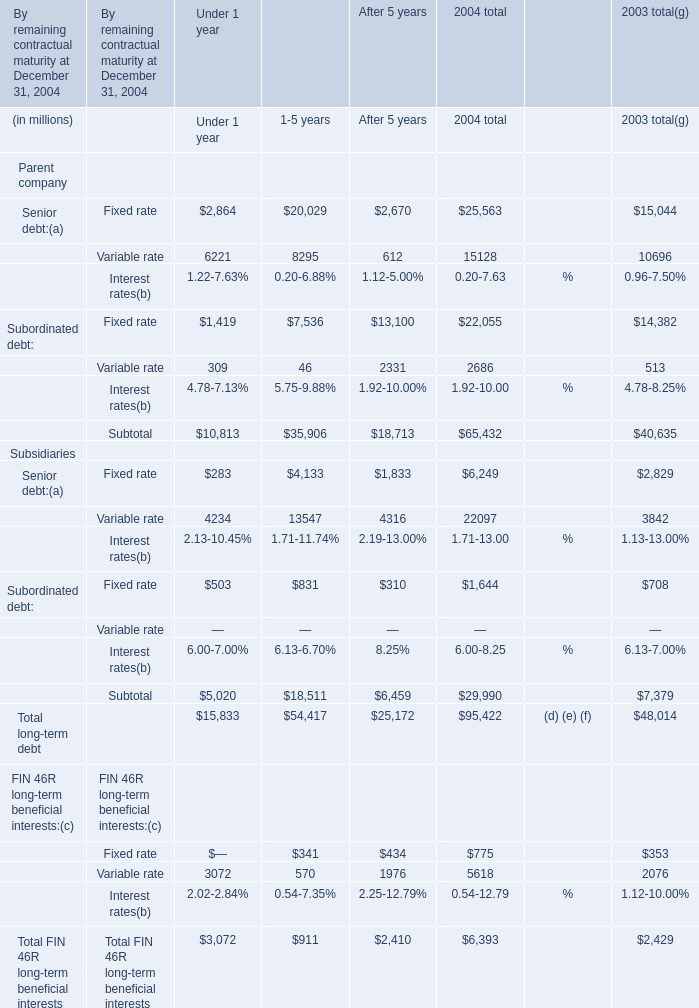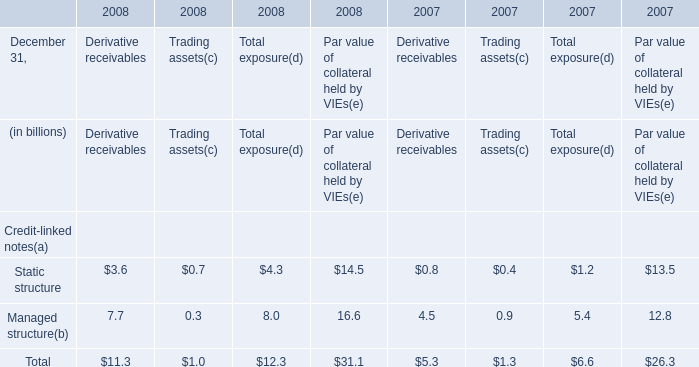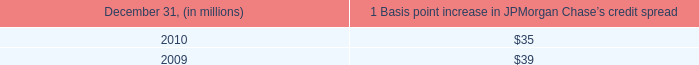on what percent of trading days were there market gains above $ 210 million? 
Computations: (12 / 261)
Answer: 0.04598. 